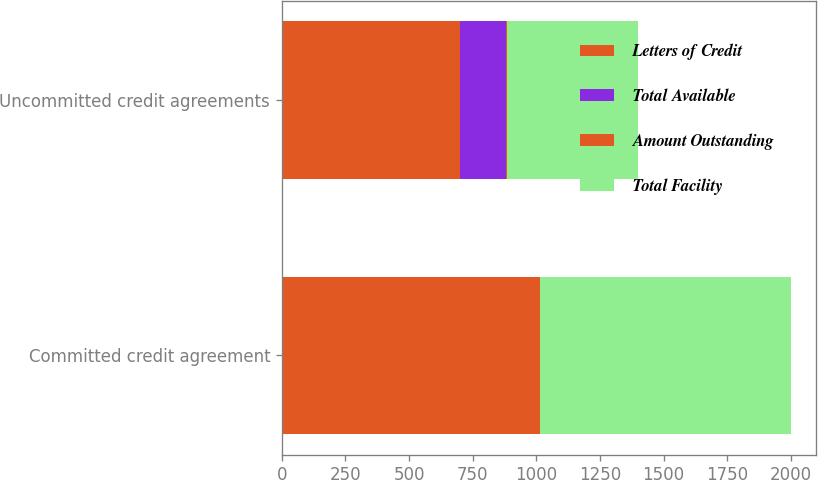Convert chart to OTSL. <chart><loc_0><loc_0><loc_500><loc_500><stacked_bar_chart><ecel><fcel>Committed credit agreement<fcel>Uncommitted credit agreements<nl><fcel>Letters of Credit<fcel>1000<fcel>700.2<nl><fcel>Total Available<fcel>0<fcel>179.1<nl><fcel>Amount Outstanding<fcel>14.3<fcel>4.2<nl><fcel>Total Facility<fcel>985.7<fcel>516.9<nl></chart> 